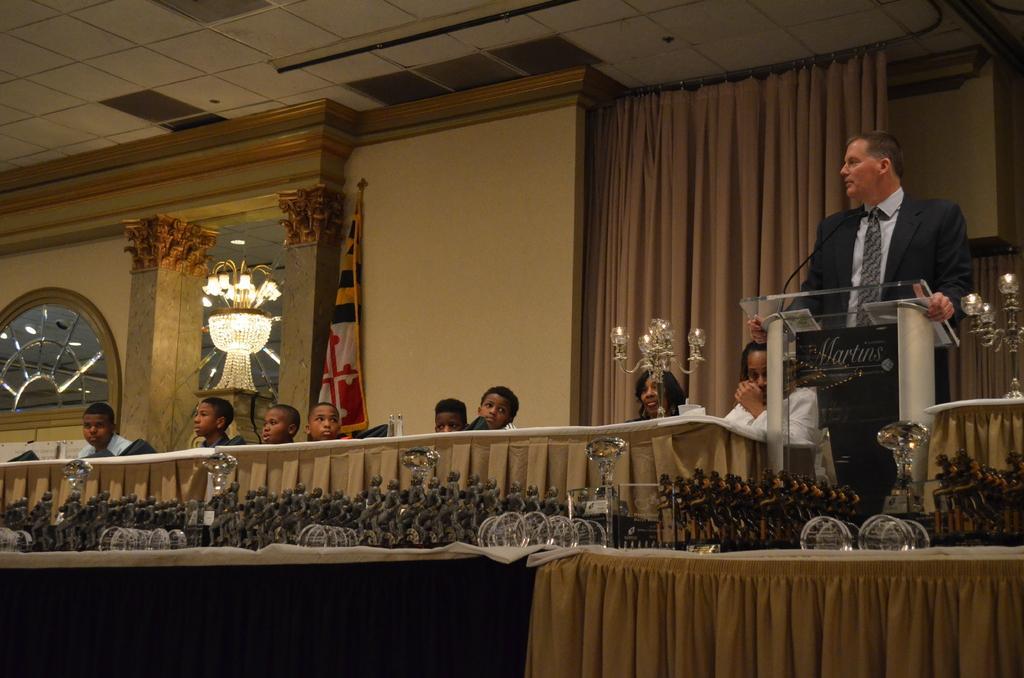In one or two sentences, can you explain what this image depicts? In this picture we can see a few trophies. We can see a microphone and a person standing in front of the podium. There is some text visible on a board. We can see the candles on the candle stands. We can see a few kids and some people. There is a flag, clothes and other objects. 